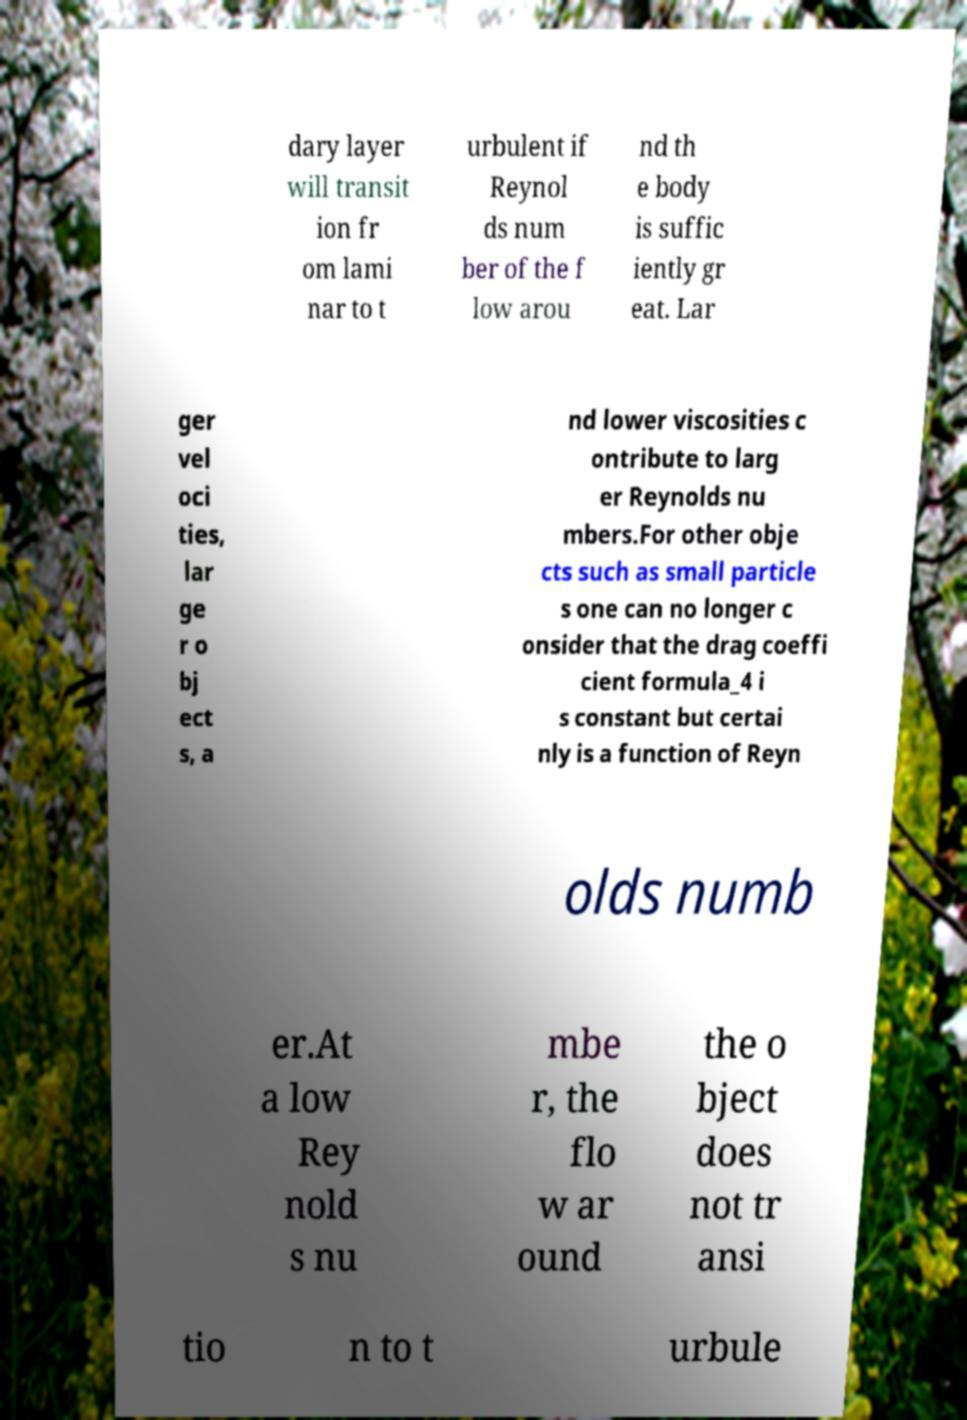Could you extract and type out the text from this image? dary layer will transit ion fr om lami nar to t urbulent if Reynol ds num ber of the f low arou nd th e body is suffic iently gr eat. Lar ger vel oci ties, lar ge r o bj ect s, a nd lower viscosities c ontribute to larg er Reynolds nu mbers.For other obje cts such as small particle s one can no longer c onsider that the drag coeffi cient formula_4 i s constant but certai nly is a function of Reyn olds numb er.At a low Rey nold s nu mbe r, the flo w ar ound the o bject does not tr ansi tio n to t urbule 